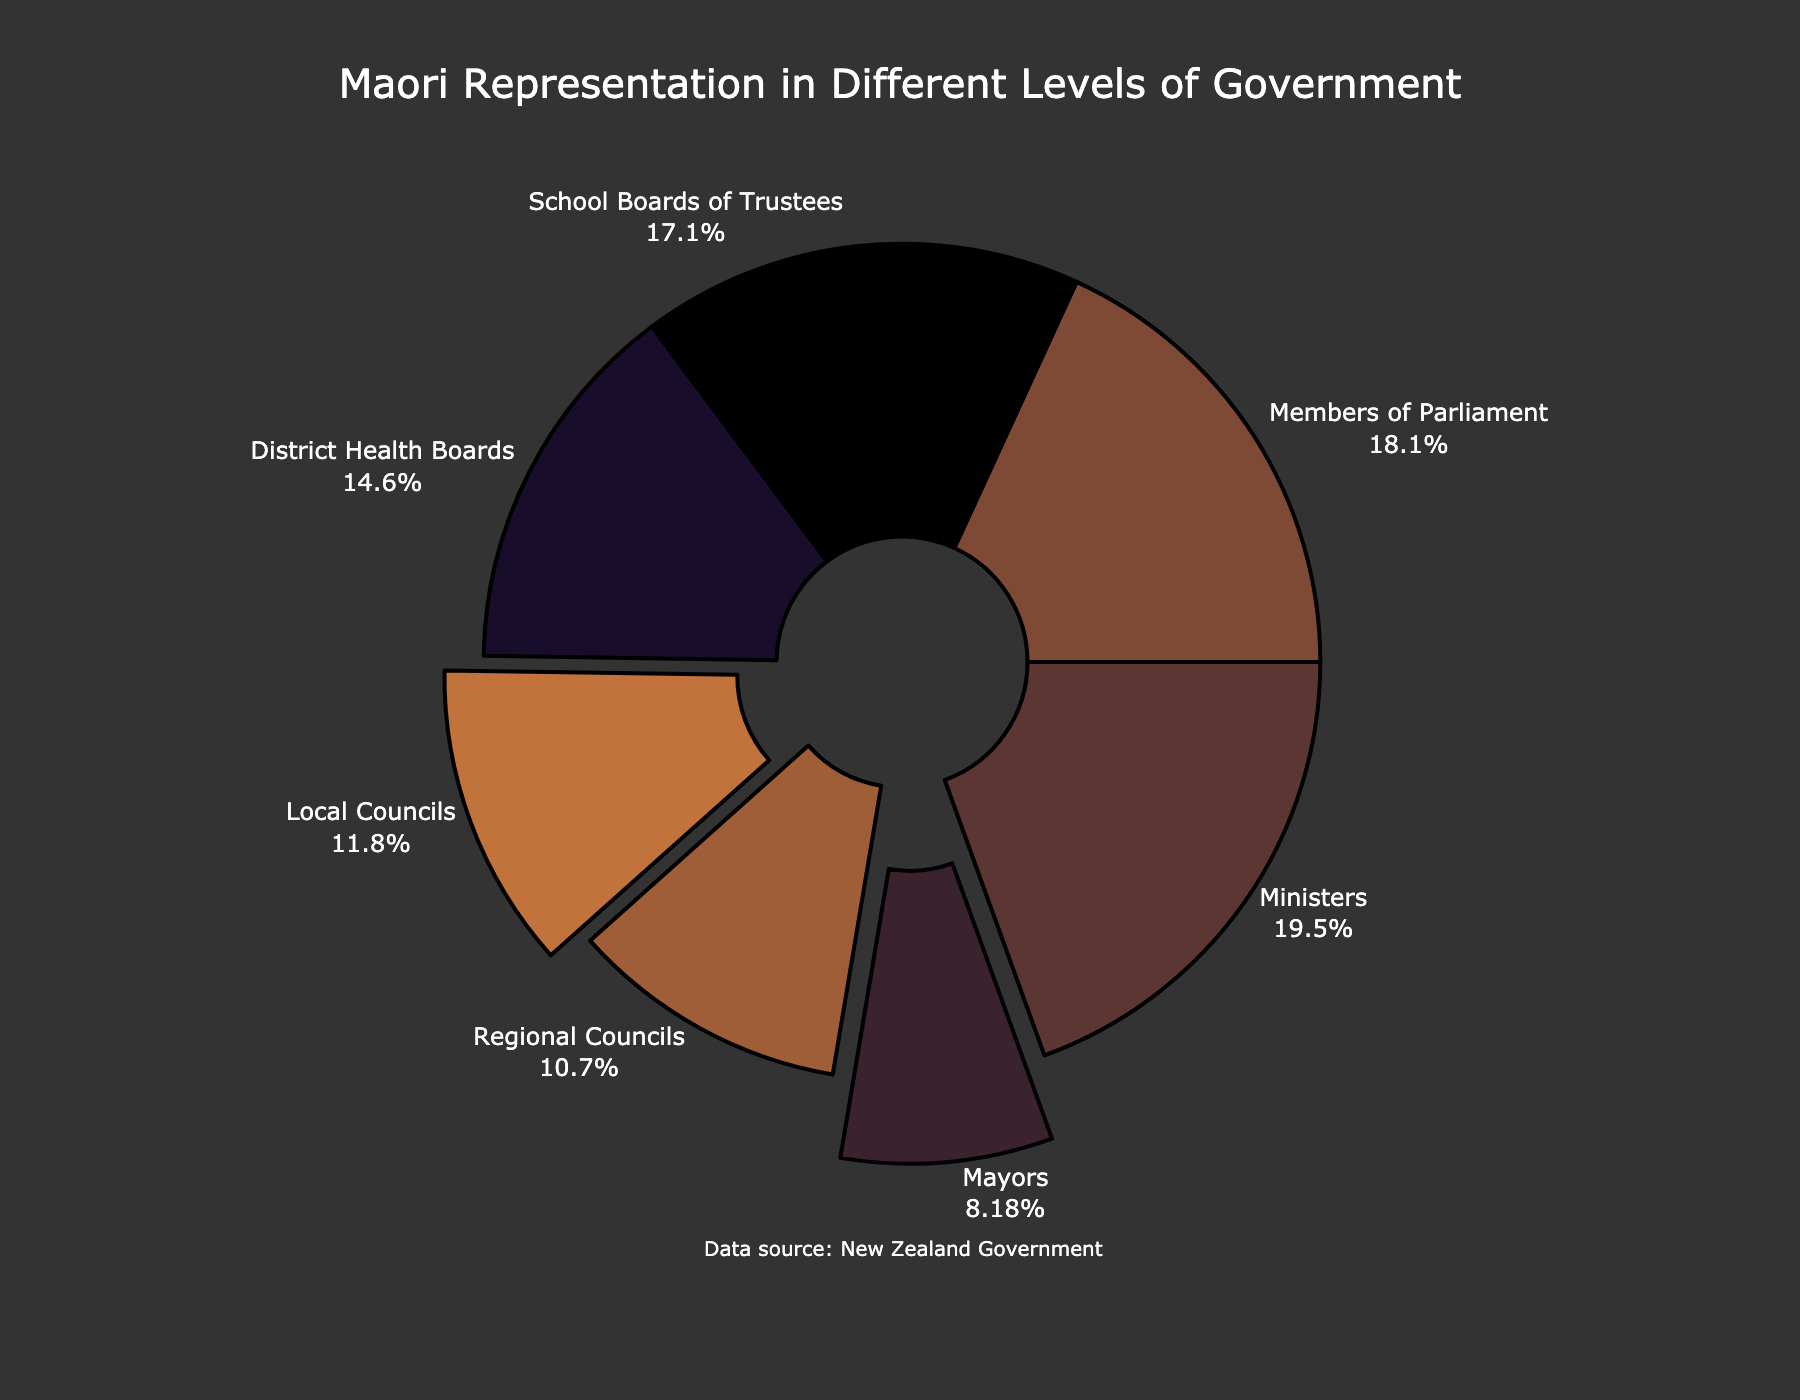What's the highest percentage of Maori representation in any level of government? Look at all the values and identify the maximum percentage. The highest percentage is 25.0% among Ministers.
Answer: 25.0% Which level of government has the lowest percentage of Maori representation? Look at all the values and identify the minimum percentage. The lowest percentage is 10.5% among Mayors.
Answer: Mayors Is Maori representation higher in local councils or regional councils? Compare the percentages for Local Councils (15.2%) and Regional Councils (13.8%). The representation is higher in Local Councils.
Answer: Local Councils What is the difference between the Maori representation in Members of Parliament and Mayors? Subtract the percentage of Mayors (10.5%) from Members of Parliament (23.3%). 23.3% - 10.5% = 12.8%.
Answer: 12.8% What is the total Maori representation percentage across all levels of government mentioned? Add up all the percentages: 15.2% + 13.8% + 23.3% + 25.0% + 10.5% + 18.7% + 21.9% = 128.4%.
Answer: 128.4% What's the average Maori representation in District Health Boards, School Boards of Trustees, and Members of Parliament? Add the percentages together and divide by 3: (18.7% + 21.9% + 23.3%)/3 = 21.3%.
Answer: 21.3% List the levels of government in descending order of Maori representation. Rank the levels based on their percentages: Ministers (25.0%), Members of Parliament (23.3%), School Boards of Trustees (21.9%), District Health Boards (18.7%), Local Councils (15.2%), Regional Councils (13.8%), Mayors (10.5%).
Answer: Ministers, Members of Parliament, School Boards of Trustees, District Health Boards, Local Councils, Regional Councils, Mayors Which level of government gets pulled out more prominently in the pie chart, Mayors or Local Councils? The visual feature of "pull" is more pronounced for Mayors (10.5%) with a larger segment pulled out compared to Local Councils (15.2%).
Answer: Mayors Are there more levels of government with over 20% Maori representation or under 20% Maori representation? There are three levels over 20% (Ministers, Members of Parliament, School Boards of Trustees) and four under 20% (Local Councils, Regional Councils, Mayors, District Health Boards).
Answer: Under 20% 